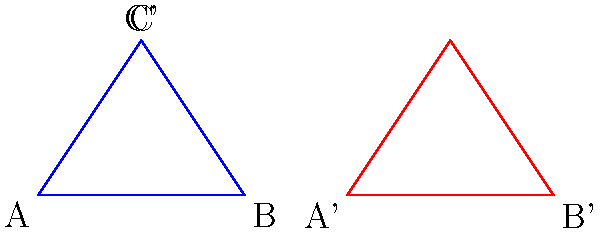A non-profit organization uses a triangular chart to represent its fundraising goal. The original chart is represented by triangle ABC, where A(0,0), B(4,0), and C(2,3). After applying a composite transformation, the chart becomes triangle A'B'C', where A'(6,0), B'(10,0), and C'(8,3). Determine the composite transformation applied to the original chart. To determine the composite transformation, we need to analyze how the original triangle ABC was transformed into A'B'C'. Let's break it down step-by-step:

1. Compare the coordinates of corresponding points:
   A(0,0) → A'(6,0)
   B(4,0) → B'(10,0)
   C(2,3) → C'(8,3)

2. Observe the changes in x-coordinates:
   A: 0 → 6 (increased by 6)
   B: 4 → 10 (increased by 6)
   C: 2 → 8 (increased by 6)

3. Observe the changes in y-coordinates:
   A: 0 → 0 (no change)
   B: 0 → 0 (no change)
   C: 3 → 3 (no change)

4. Analyze the transformation:
   - All x-coordinates increased by 6 units
   - All y-coordinates remained the same

5. Conclude the transformation:
   The composite transformation is a translation of 6 units to the right, which can be represented as T(6,0).
Answer: Translation T(6,0) 